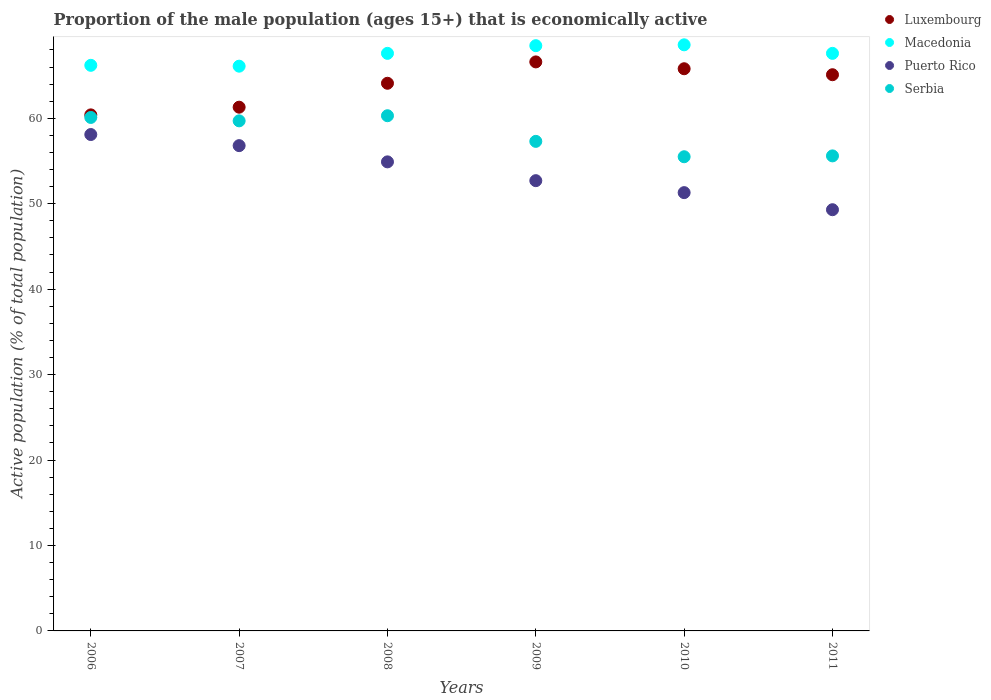How many different coloured dotlines are there?
Your answer should be compact. 4. Is the number of dotlines equal to the number of legend labels?
Your answer should be compact. Yes. What is the proportion of the male population that is economically active in Serbia in 2011?
Offer a terse response. 55.6. Across all years, what is the maximum proportion of the male population that is economically active in Serbia?
Offer a terse response. 60.3. Across all years, what is the minimum proportion of the male population that is economically active in Serbia?
Your answer should be very brief. 55.5. In which year was the proportion of the male population that is economically active in Macedonia maximum?
Provide a short and direct response. 2010. In which year was the proportion of the male population that is economically active in Serbia minimum?
Offer a very short reply. 2010. What is the total proportion of the male population that is economically active in Luxembourg in the graph?
Give a very brief answer. 383.3. What is the difference between the proportion of the male population that is economically active in Luxembourg in 2008 and that in 2011?
Give a very brief answer. -1. What is the difference between the proportion of the male population that is economically active in Luxembourg in 2011 and the proportion of the male population that is economically active in Serbia in 2008?
Keep it short and to the point. 4.8. What is the average proportion of the male population that is economically active in Luxembourg per year?
Provide a succinct answer. 63.88. In the year 2008, what is the difference between the proportion of the male population that is economically active in Luxembourg and proportion of the male population that is economically active in Macedonia?
Give a very brief answer. -3.5. In how many years, is the proportion of the male population that is economically active in Serbia greater than 22 %?
Ensure brevity in your answer.  6. What is the ratio of the proportion of the male population that is economically active in Macedonia in 2010 to that in 2011?
Provide a short and direct response. 1.01. Is the proportion of the male population that is economically active in Luxembourg in 2006 less than that in 2010?
Provide a short and direct response. Yes. Is the difference between the proportion of the male population that is economically active in Luxembourg in 2008 and 2009 greater than the difference between the proportion of the male population that is economically active in Macedonia in 2008 and 2009?
Your response must be concise. No. What is the difference between the highest and the second highest proportion of the male population that is economically active in Luxembourg?
Offer a terse response. 0.8. What is the difference between the highest and the lowest proportion of the male population that is economically active in Luxembourg?
Give a very brief answer. 6.2. In how many years, is the proportion of the male population that is economically active in Serbia greater than the average proportion of the male population that is economically active in Serbia taken over all years?
Give a very brief answer. 3. Is the sum of the proportion of the male population that is economically active in Luxembourg in 2008 and 2011 greater than the maximum proportion of the male population that is economically active in Macedonia across all years?
Your response must be concise. Yes. Is it the case that in every year, the sum of the proportion of the male population that is economically active in Puerto Rico and proportion of the male population that is economically active in Luxembourg  is greater than the sum of proportion of the male population that is economically active in Serbia and proportion of the male population that is economically active in Macedonia?
Offer a very short reply. No. Is it the case that in every year, the sum of the proportion of the male population that is economically active in Serbia and proportion of the male population that is economically active in Puerto Rico  is greater than the proportion of the male population that is economically active in Luxembourg?
Offer a very short reply. Yes. Does the proportion of the male population that is economically active in Serbia monotonically increase over the years?
Give a very brief answer. No. Is the proportion of the male population that is economically active in Puerto Rico strictly greater than the proportion of the male population that is economically active in Macedonia over the years?
Offer a terse response. No. How many dotlines are there?
Keep it short and to the point. 4. How many years are there in the graph?
Your answer should be compact. 6. What is the difference between two consecutive major ticks on the Y-axis?
Your answer should be compact. 10. Are the values on the major ticks of Y-axis written in scientific E-notation?
Ensure brevity in your answer.  No. Does the graph contain any zero values?
Make the answer very short. No. Where does the legend appear in the graph?
Your answer should be compact. Top right. How many legend labels are there?
Provide a succinct answer. 4. What is the title of the graph?
Your response must be concise. Proportion of the male population (ages 15+) that is economically active. Does "Peru" appear as one of the legend labels in the graph?
Make the answer very short. No. What is the label or title of the Y-axis?
Your response must be concise. Active population (% of total population). What is the Active population (% of total population) of Luxembourg in 2006?
Provide a succinct answer. 60.4. What is the Active population (% of total population) in Macedonia in 2006?
Provide a short and direct response. 66.2. What is the Active population (% of total population) of Puerto Rico in 2006?
Make the answer very short. 58.1. What is the Active population (% of total population) of Serbia in 2006?
Offer a very short reply. 60.1. What is the Active population (% of total population) of Luxembourg in 2007?
Offer a terse response. 61.3. What is the Active population (% of total population) of Macedonia in 2007?
Your answer should be compact. 66.1. What is the Active population (% of total population) in Puerto Rico in 2007?
Your response must be concise. 56.8. What is the Active population (% of total population) in Serbia in 2007?
Provide a short and direct response. 59.7. What is the Active population (% of total population) of Luxembourg in 2008?
Your answer should be compact. 64.1. What is the Active population (% of total population) of Macedonia in 2008?
Provide a short and direct response. 67.6. What is the Active population (% of total population) in Puerto Rico in 2008?
Offer a very short reply. 54.9. What is the Active population (% of total population) in Serbia in 2008?
Provide a short and direct response. 60.3. What is the Active population (% of total population) of Luxembourg in 2009?
Your answer should be compact. 66.6. What is the Active population (% of total population) in Macedonia in 2009?
Your answer should be compact. 68.5. What is the Active population (% of total population) in Puerto Rico in 2009?
Provide a succinct answer. 52.7. What is the Active population (% of total population) in Serbia in 2009?
Provide a short and direct response. 57.3. What is the Active population (% of total population) of Luxembourg in 2010?
Offer a terse response. 65.8. What is the Active population (% of total population) of Macedonia in 2010?
Provide a succinct answer. 68.6. What is the Active population (% of total population) in Puerto Rico in 2010?
Ensure brevity in your answer.  51.3. What is the Active population (% of total population) of Serbia in 2010?
Offer a terse response. 55.5. What is the Active population (% of total population) of Luxembourg in 2011?
Your response must be concise. 65.1. What is the Active population (% of total population) of Macedonia in 2011?
Provide a short and direct response. 67.6. What is the Active population (% of total population) in Puerto Rico in 2011?
Give a very brief answer. 49.3. What is the Active population (% of total population) of Serbia in 2011?
Your response must be concise. 55.6. Across all years, what is the maximum Active population (% of total population) of Luxembourg?
Keep it short and to the point. 66.6. Across all years, what is the maximum Active population (% of total population) of Macedonia?
Make the answer very short. 68.6. Across all years, what is the maximum Active population (% of total population) of Puerto Rico?
Your answer should be compact. 58.1. Across all years, what is the maximum Active population (% of total population) of Serbia?
Make the answer very short. 60.3. Across all years, what is the minimum Active population (% of total population) of Luxembourg?
Offer a terse response. 60.4. Across all years, what is the minimum Active population (% of total population) in Macedonia?
Provide a succinct answer. 66.1. Across all years, what is the minimum Active population (% of total population) of Puerto Rico?
Offer a very short reply. 49.3. Across all years, what is the minimum Active population (% of total population) in Serbia?
Your response must be concise. 55.5. What is the total Active population (% of total population) in Luxembourg in the graph?
Offer a terse response. 383.3. What is the total Active population (% of total population) in Macedonia in the graph?
Your answer should be very brief. 404.6. What is the total Active population (% of total population) in Puerto Rico in the graph?
Ensure brevity in your answer.  323.1. What is the total Active population (% of total population) in Serbia in the graph?
Your answer should be compact. 348.5. What is the difference between the Active population (% of total population) in Macedonia in 2006 and that in 2007?
Ensure brevity in your answer.  0.1. What is the difference between the Active population (% of total population) in Puerto Rico in 2006 and that in 2007?
Offer a very short reply. 1.3. What is the difference between the Active population (% of total population) of Serbia in 2006 and that in 2007?
Ensure brevity in your answer.  0.4. What is the difference between the Active population (% of total population) in Puerto Rico in 2006 and that in 2008?
Offer a terse response. 3.2. What is the difference between the Active population (% of total population) in Luxembourg in 2006 and that in 2009?
Provide a short and direct response. -6.2. What is the difference between the Active population (% of total population) of Puerto Rico in 2006 and that in 2009?
Ensure brevity in your answer.  5.4. What is the difference between the Active population (% of total population) of Serbia in 2006 and that in 2009?
Provide a short and direct response. 2.8. What is the difference between the Active population (% of total population) of Macedonia in 2006 and that in 2010?
Your response must be concise. -2.4. What is the difference between the Active population (% of total population) in Puerto Rico in 2006 and that in 2010?
Offer a terse response. 6.8. What is the difference between the Active population (% of total population) of Serbia in 2006 and that in 2010?
Keep it short and to the point. 4.6. What is the difference between the Active population (% of total population) in Luxembourg in 2006 and that in 2011?
Give a very brief answer. -4.7. What is the difference between the Active population (% of total population) of Macedonia in 2006 and that in 2011?
Offer a very short reply. -1.4. What is the difference between the Active population (% of total population) of Serbia in 2007 and that in 2008?
Provide a short and direct response. -0.6. What is the difference between the Active population (% of total population) in Puerto Rico in 2007 and that in 2009?
Keep it short and to the point. 4.1. What is the difference between the Active population (% of total population) of Luxembourg in 2007 and that in 2010?
Offer a very short reply. -4.5. What is the difference between the Active population (% of total population) of Puerto Rico in 2007 and that in 2010?
Your response must be concise. 5.5. What is the difference between the Active population (% of total population) in Serbia in 2007 and that in 2010?
Provide a short and direct response. 4.2. What is the difference between the Active population (% of total population) of Luxembourg in 2007 and that in 2011?
Provide a succinct answer. -3.8. What is the difference between the Active population (% of total population) in Macedonia in 2008 and that in 2009?
Offer a very short reply. -0.9. What is the difference between the Active population (% of total population) of Puerto Rico in 2008 and that in 2009?
Keep it short and to the point. 2.2. What is the difference between the Active population (% of total population) of Luxembourg in 2008 and that in 2010?
Offer a very short reply. -1.7. What is the difference between the Active population (% of total population) in Macedonia in 2008 and that in 2010?
Keep it short and to the point. -1. What is the difference between the Active population (% of total population) of Luxembourg in 2008 and that in 2011?
Offer a very short reply. -1. What is the difference between the Active population (% of total population) in Serbia in 2009 and that in 2010?
Provide a short and direct response. 1.8. What is the difference between the Active population (% of total population) in Luxembourg in 2009 and that in 2011?
Provide a short and direct response. 1.5. What is the difference between the Active population (% of total population) in Macedonia in 2009 and that in 2011?
Provide a succinct answer. 0.9. What is the difference between the Active population (% of total population) of Puerto Rico in 2009 and that in 2011?
Ensure brevity in your answer.  3.4. What is the difference between the Active population (% of total population) of Serbia in 2009 and that in 2011?
Your answer should be compact. 1.7. What is the difference between the Active population (% of total population) in Serbia in 2010 and that in 2011?
Your answer should be compact. -0.1. What is the difference between the Active population (% of total population) in Luxembourg in 2006 and the Active population (% of total population) in Macedonia in 2007?
Provide a succinct answer. -5.7. What is the difference between the Active population (% of total population) in Macedonia in 2006 and the Active population (% of total population) in Puerto Rico in 2007?
Keep it short and to the point. 9.4. What is the difference between the Active population (% of total population) in Macedonia in 2006 and the Active population (% of total population) in Serbia in 2007?
Provide a succinct answer. 6.5. What is the difference between the Active population (% of total population) of Luxembourg in 2006 and the Active population (% of total population) of Macedonia in 2008?
Your answer should be very brief. -7.2. What is the difference between the Active population (% of total population) of Luxembourg in 2006 and the Active population (% of total population) of Puerto Rico in 2008?
Provide a succinct answer. 5.5. What is the difference between the Active population (% of total population) in Luxembourg in 2006 and the Active population (% of total population) in Serbia in 2008?
Ensure brevity in your answer.  0.1. What is the difference between the Active population (% of total population) in Macedonia in 2006 and the Active population (% of total population) in Puerto Rico in 2008?
Offer a very short reply. 11.3. What is the difference between the Active population (% of total population) in Luxembourg in 2006 and the Active population (% of total population) in Macedonia in 2010?
Ensure brevity in your answer.  -8.2. What is the difference between the Active population (% of total population) of Macedonia in 2006 and the Active population (% of total population) of Serbia in 2010?
Offer a terse response. 10.7. What is the difference between the Active population (% of total population) in Luxembourg in 2006 and the Active population (% of total population) in Macedonia in 2011?
Ensure brevity in your answer.  -7.2. What is the difference between the Active population (% of total population) in Luxembourg in 2006 and the Active population (% of total population) in Puerto Rico in 2011?
Your answer should be very brief. 11.1. What is the difference between the Active population (% of total population) in Luxembourg in 2006 and the Active population (% of total population) in Serbia in 2011?
Ensure brevity in your answer.  4.8. What is the difference between the Active population (% of total population) of Macedonia in 2006 and the Active population (% of total population) of Serbia in 2011?
Provide a succinct answer. 10.6. What is the difference between the Active population (% of total population) of Luxembourg in 2007 and the Active population (% of total population) of Puerto Rico in 2008?
Give a very brief answer. 6.4. What is the difference between the Active population (% of total population) in Luxembourg in 2007 and the Active population (% of total population) in Serbia in 2008?
Provide a succinct answer. 1. What is the difference between the Active population (% of total population) in Puerto Rico in 2007 and the Active population (% of total population) in Serbia in 2008?
Your response must be concise. -3.5. What is the difference between the Active population (% of total population) of Macedonia in 2007 and the Active population (% of total population) of Puerto Rico in 2009?
Your answer should be compact. 13.4. What is the difference between the Active population (% of total population) of Luxembourg in 2007 and the Active population (% of total population) of Macedonia in 2010?
Ensure brevity in your answer.  -7.3. What is the difference between the Active population (% of total population) of Macedonia in 2007 and the Active population (% of total population) of Serbia in 2010?
Provide a short and direct response. 10.6. What is the difference between the Active population (% of total population) of Puerto Rico in 2007 and the Active population (% of total population) of Serbia in 2010?
Provide a short and direct response. 1.3. What is the difference between the Active population (% of total population) in Luxembourg in 2007 and the Active population (% of total population) in Puerto Rico in 2011?
Provide a succinct answer. 12. What is the difference between the Active population (% of total population) in Luxembourg in 2008 and the Active population (% of total population) in Macedonia in 2009?
Provide a succinct answer. -4.4. What is the difference between the Active population (% of total population) in Luxembourg in 2008 and the Active population (% of total population) in Puerto Rico in 2009?
Give a very brief answer. 11.4. What is the difference between the Active population (% of total population) of Luxembourg in 2008 and the Active population (% of total population) of Serbia in 2009?
Provide a succinct answer. 6.8. What is the difference between the Active population (% of total population) of Macedonia in 2008 and the Active population (% of total population) of Puerto Rico in 2009?
Your answer should be very brief. 14.9. What is the difference between the Active population (% of total population) in Macedonia in 2008 and the Active population (% of total population) in Serbia in 2009?
Your answer should be very brief. 10.3. What is the difference between the Active population (% of total population) of Luxembourg in 2008 and the Active population (% of total population) of Macedonia in 2010?
Ensure brevity in your answer.  -4.5. What is the difference between the Active population (% of total population) in Luxembourg in 2008 and the Active population (% of total population) in Puerto Rico in 2010?
Offer a terse response. 12.8. What is the difference between the Active population (% of total population) of Luxembourg in 2008 and the Active population (% of total population) of Serbia in 2010?
Provide a short and direct response. 8.6. What is the difference between the Active population (% of total population) in Macedonia in 2008 and the Active population (% of total population) in Serbia in 2010?
Your response must be concise. 12.1. What is the difference between the Active population (% of total population) of Luxembourg in 2008 and the Active population (% of total population) of Macedonia in 2011?
Keep it short and to the point. -3.5. What is the difference between the Active population (% of total population) of Luxembourg in 2008 and the Active population (% of total population) of Puerto Rico in 2011?
Your answer should be compact. 14.8. What is the difference between the Active population (% of total population) of Luxembourg in 2008 and the Active population (% of total population) of Serbia in 2011?
Offer a very short reply. 8.5. What is the difference between the Active population (% of total population) in Macedonia in 2008 and the Active population (% of total population) in Serbia in 2011?
Your answer should be compact. 12. What is the difference between the Active population (% of total population) of Luxembourg in 2009 and the Active population (% of total population) of Macedonia in 2010?
Give a very brief answer. -2. What is the difference between the Active population (% of total population) of Luxembourg in 2009 and the Active population (% of total population) of Serbia in 2010?
Provide a succinct answer. 11.1. What is the difference between the Active population (% of total population) of Puerto Rico in 2009 and the Active population (% of total population) of Serbia in 2010?
Offer a terse response. -2.8. What is the difference between the Active population (% of total population) in Luxembourg in 2009 and the Active population (% of total population) in Macedonia in 2011?
Provide a short and direct response. -1. What is the difference between the Active population (% of total population) of Macedonia in 2009 and the Active population (% of total population) of Serbia in 2011?
Your answer should be very brief. 12.9. What is the difference between the Active population (% of total population) in Luxembourg in 2010 and the Active population (% of total population) in Serbia in 2011?
Ensure brevity in your answer.  10.2. What is the difference between the Active population (% of total population) in Macedonia in 2010 and the Active population (% of total population) in Puerto Rico in 2011?
Keep it short and to the point. 19.3. What is the difference between the Active population (% of total population) of Macedonia in 2010 and the Active population (% of total population) of Serbia in 2011?
Provide a short and direct response. 13. What is the average Active population (% of total population) of Luxembourg per year?
Ensure brevity in your answer.  63.88. What is the average Active population (% of total population) of Macedonia per year?
Your answer should be compact. 67.43. What is the average Active population (% of total population) in Puerto Rico per year?
Your answer should be compact. 53.85. What is the average Active population (% of total population) of Serbia per year?
Provide a succinct answer. 58.08. In the year 2006, what is the difference between the Active population (% of total population) of Luxembourg and Active population (% of total population) of Serbia?
Provide a short and direct response. 0.3. In the year 2006, what is the difference between the Active population (% of total population) of Macedonia and Active population (% of total population) of Puerto Rico?
Your response must be concise. 8.1. In the year 2007, what is the difference between the Active population (% of total population) of Luxembourg and Active population (% of total population) of Serbia?
Provide a succinct answer. 1.6. In the year 2008, what is the difference between the Active population (% of total population) in Luxembourg and Active population (% of total population) in Macedonia?
Provide a short and direct response. -3.5. In the year 2008, what is the difference between the Active population (% of total population) in Macedonia and Active population (% of total population) in Serbia?
Keep it short and to the point. 7.3. In the year 2009, what is the difference between the Active population (% of total population) of Macedonia and Active population (% of total population) of Puerto Rico?
Your response must be concise. 15.8. In the year 2009, what is the difference between the Active population (% of total population) of Macedonia and Active population (% of total population) of Serbia?
Your response must be concise. 11.2. In the year 2010, what is the difference between the Active population (% of total population) of Luxembourg and Active population (% of total population) of Macedonia?
Provide a succinct answer. -2.8. In the year 2010, what is the difference between the Active population (% of total population) in Luxembourg and Active population (% of total population) in Puerto Rico?
Your answer should be very brief. 14.5. In the year 2011, what is the difference between the Active population (% of total population) of Luxembourg and Active population (% of total population) of Serbia?
Keep it short and to the point. 9.5. In the year 2011, what is the difference between the Active population (% of total population) in Macedonia and Active population (% of total population) in Serbia?
Keep it short and to the point. 12. What is the ratio of the Active population (% of total population) of Luxembourg in 2006 to that in 2007?
Provide a short and direct response. 0.99. What is the ratio of the Active population (% of total population) of Macedonia in 2006 to that in 2007?
Your answer should be very brief. 1. What is the ratio of the Active population (% of total population) of Puerto Rico in 2006 to that in 2007?
Your answer should be compact. 1.02. What is the ratio of the Active population (% of total population) of Serbia in 2006 to that in 2007?
Give a very brief answer. 1.01. What is the ratio of the Active population (% of total population) of Luxembourg in 2006 to that in 2008?
Offer a terse response. 0.94. What is the ratio of the Active population (% of total population) in Macedonia in 2006 to that in 2008?
Provide a short and direct response. 0.98. What is the ratio of the Active population (% of total population) of Puerto Rico in 2006 to that in 2008?
Make the answer very short. 1.06. What is the ratio of the Active population (% of total population) in Serbia in 2006 to that in 2008?
Give a very brief answer. 1. What is the ratio of the Active population (% of total population) of Luxembourg in 2006 to that in 2009?
Ensure brevity in your answer.  0.91. What is the ratio of the Active population (% of total population) of Macedonia in 2006 to that in 2009?
Your response must be concise. 0.97. What is the ratio of the Active population (% of total population) in Puerto Rico in 2006 to that in 2009?
Make the answer very short. 1.1. What is the ratio of the Active population (% of total population) of Serbia in 2006 to that in 2009?
Offer a terse response. 1.05. What is the ratio of the Active population (% of total population) of Luxembourg in 2006 to that in 2010?
Provide a short and direct response. 0.92. What is the ratio of the Active population (% of total population) in Puerto Rico in 2006 to that in 2010?
Offer a very short reply. 1.13. What is the ratio of the Active population (% of total population) of Serbia in 2006 to that in 2010?
Your answer should be very brief. 1.08. What is the ratio of the Active population (% of total population) of Luxembourg in 2006 to that in 2011?
Keep it short and to the point. 0.93. What is the ratio of the Active population (% of total population) in Macedonia in 2006 to that in 2011?
Make the answer very short. 0.98. What is the ratio of the Active population (% of total population) in Puerto Rico in 2006 to that in 2011?
Make the answer very short. 1.18. What is the ratio of the Active population (% of total population) of Serbia in 2006 to that in 2011?
Ensure brevity in your answer.  1.08. What is the ratio of the Active population (% of total population) in Luxembourg in 2007 to that in 2008?
Make the answer very short. 0.96. What is the ratio of the Active population (% of total population) of Macedonia in 2007 to that in 2008?
Make the answer very short. 0.98. What is the ratio of the Active population (% of total population) in Puerto Rico in 2007 to that in 2008?
Ensure brevity in your answer.  1.03. What is the ratio of the Active population (% of total population) in Serbia in 2007 to that in 2008?
Keep it short and to the point. 0.99. What is the ratio of the Active population (% of total population) in Luxembourg in 2007 to that in 2009?
Provide a succinct answer. 0.92. What is the ratio of the Active population (% of total population) in Puerto Rico in 2007 to that in 2009?
Ensure brevity in your answer.  1.08. What is the ratio of the Active population (% of total population) in Serbia in 2007 to that in 2009?
Keep it short and to the point. 1.04. What is the ratio of the Active population (% of total population) in Luxembourg in 2007 to that in 2010?
Your answer should be very brief. 0.93. What is the ratio of the Active population (% of total population) of Macedonia in 2007 to that in 2010?
Your answer should be very brief. 0.96. What is the ratio of the Active population (% of total population) of Puerto Rico in 2007 to that in 2010?
Provide a short and direct response. 1.11. What is the ratio of the Active population (% of total population) in Serbia in 2007 to that in 2010?
Make the answer very short. 1.08. What is the ratio of the Active population (% of total population) in Luxembourg in 2007 to that in 2011?
Provide a short and direct response. 0.94. What is the ratio of the Active population (% of total population) in Macedonia in 2007 to that in 2011?
Ensure brevity in your answer.  0.98. What is the ratio of the Active population (% of total population) of Puerto Rico in 2007 to that in 2011?
Provide a succinct answer. 1.15. What is the ratio of the Active population (% of total population) of Serbia in 2007 to that in 2011?
Provide a short and direct response. 1.07. What is the ratio of the Active population (% of total population) of Luxembourg in 2008 to that in 2009?
Offer a very short reply. 0.96. What is the ratio of the Active population (% of total population) of Macedonia in 2008 to that in 2009?
Your answer should be very brief. 0.99. What is the ratio of the Active population (% of total population) of Puerto Rico in 2008 to that in 2009?
Ensure brevity in your answer.  1.04. What is the ratio of the Active population (% of total population) of Serbia in 2008 to that in 2009?
Keep it short and to the point. 1.05. What is the ratio of the Active population (% of total population) of Luxembourg in 2008 to that in 2010?
Offer a very short reply. 0.97. What is the ratio of the Active population (% of total population) of Macedonia in 2008 to that in 2010?
Your response must be concise. 0.99. What is the ratio of the Active population (% of total population) in Puerto Rico in 2008 to that in 2010?
Ensure brevity in your answer.  1.07. What is the ratio of the Active population (% of total population) in Serbia in 2008 to that in 2010?
Your answer should be compact. 1.09. What is the ratio of the Active population (% of total population) of Luxembourg in 2008 to that in 2011?
Make the answer very short. 0.98. What is the ratio of the Active population (% of total population) of Puerto Rico in 2008 to that in 2011?
Your response must be concise. 1.11. What is the ratio of the Active population (% of total population) of Serbia in 2008 to that in 2011?
Your answer should be very brief. 1.08. What is the ratio of the Active population (% of total population) in Luxembourg in 2009 to that in 2010?
Make the answer very short. 1.01. What is the ratio of the Active population (% of total population) in Puerto Rico in 2009 to that in 2010?
Keep it short and to the point. 1.03. What is the ratio of the Active population (% of total population) in Serbia in 2009 to that in 2010?
Your answer should be compact. 1.03. What is the ratio of the Active population (% of total population) of Luxembourg in 2009 to that in 2011?
Your response must be concise. 1.02. What is the ratio of the Active population (% of total population) of Macedonia in 2009 to that in 2011?
Make the answer very short. 1.01. What is the ratio of the Active population (% of total population) of Puerto Rico in 2009 to that in 2011?
Offer a very short reply. 1.07. What is the ratio of the Active population (% of total population) in Serbia in 2009 to that in 2011?
Offer a terse response. 1.03. What is the ratio of the Active population (% of total population) of Luxembourg in 2010 to that in 2011?
Keep it short and to the point. 1.01. What is the ratio of the Active population (% of total population) in Macedonia in 2010 to that in 2011?
Provide a succinct answer. 1.01. What is the ratio of the Active population (% of total population) in Puerto Rico in 2010 to that in 2011?
Provide a short and direct response. 1.04. What is the difference between the highest and the second highest Active population (% of total population) in Luxembourg?
Ensure brevity in your answer.  0.8. What is the difference between the highest and the lowest Active population (% of total population) in Luxembourg?
Provide a succinct answer. 6.2. What is the difference between the highest and the lowest Active population (% of total population) in Macedonia?
Offer a very short reply. 2.5. What is the difference between the highest and the lowest Active population (% of total population) in Puerto Rico?
Your response must be concise. 8.8. What is the difference between the highest and the lowest Active population (% of total population) in Serbia?
Your answer should be very brief. 4.8. 